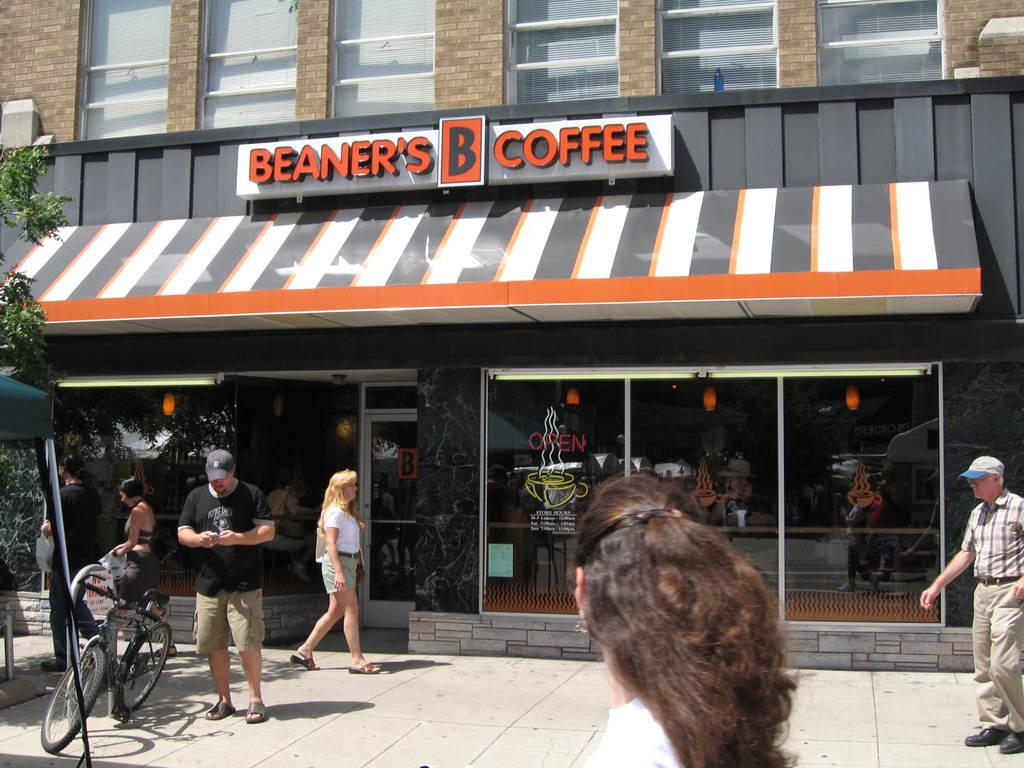<image>
Share a concise interpretation of the image provided. The front of Beaner's Coffee store with people walking by. 